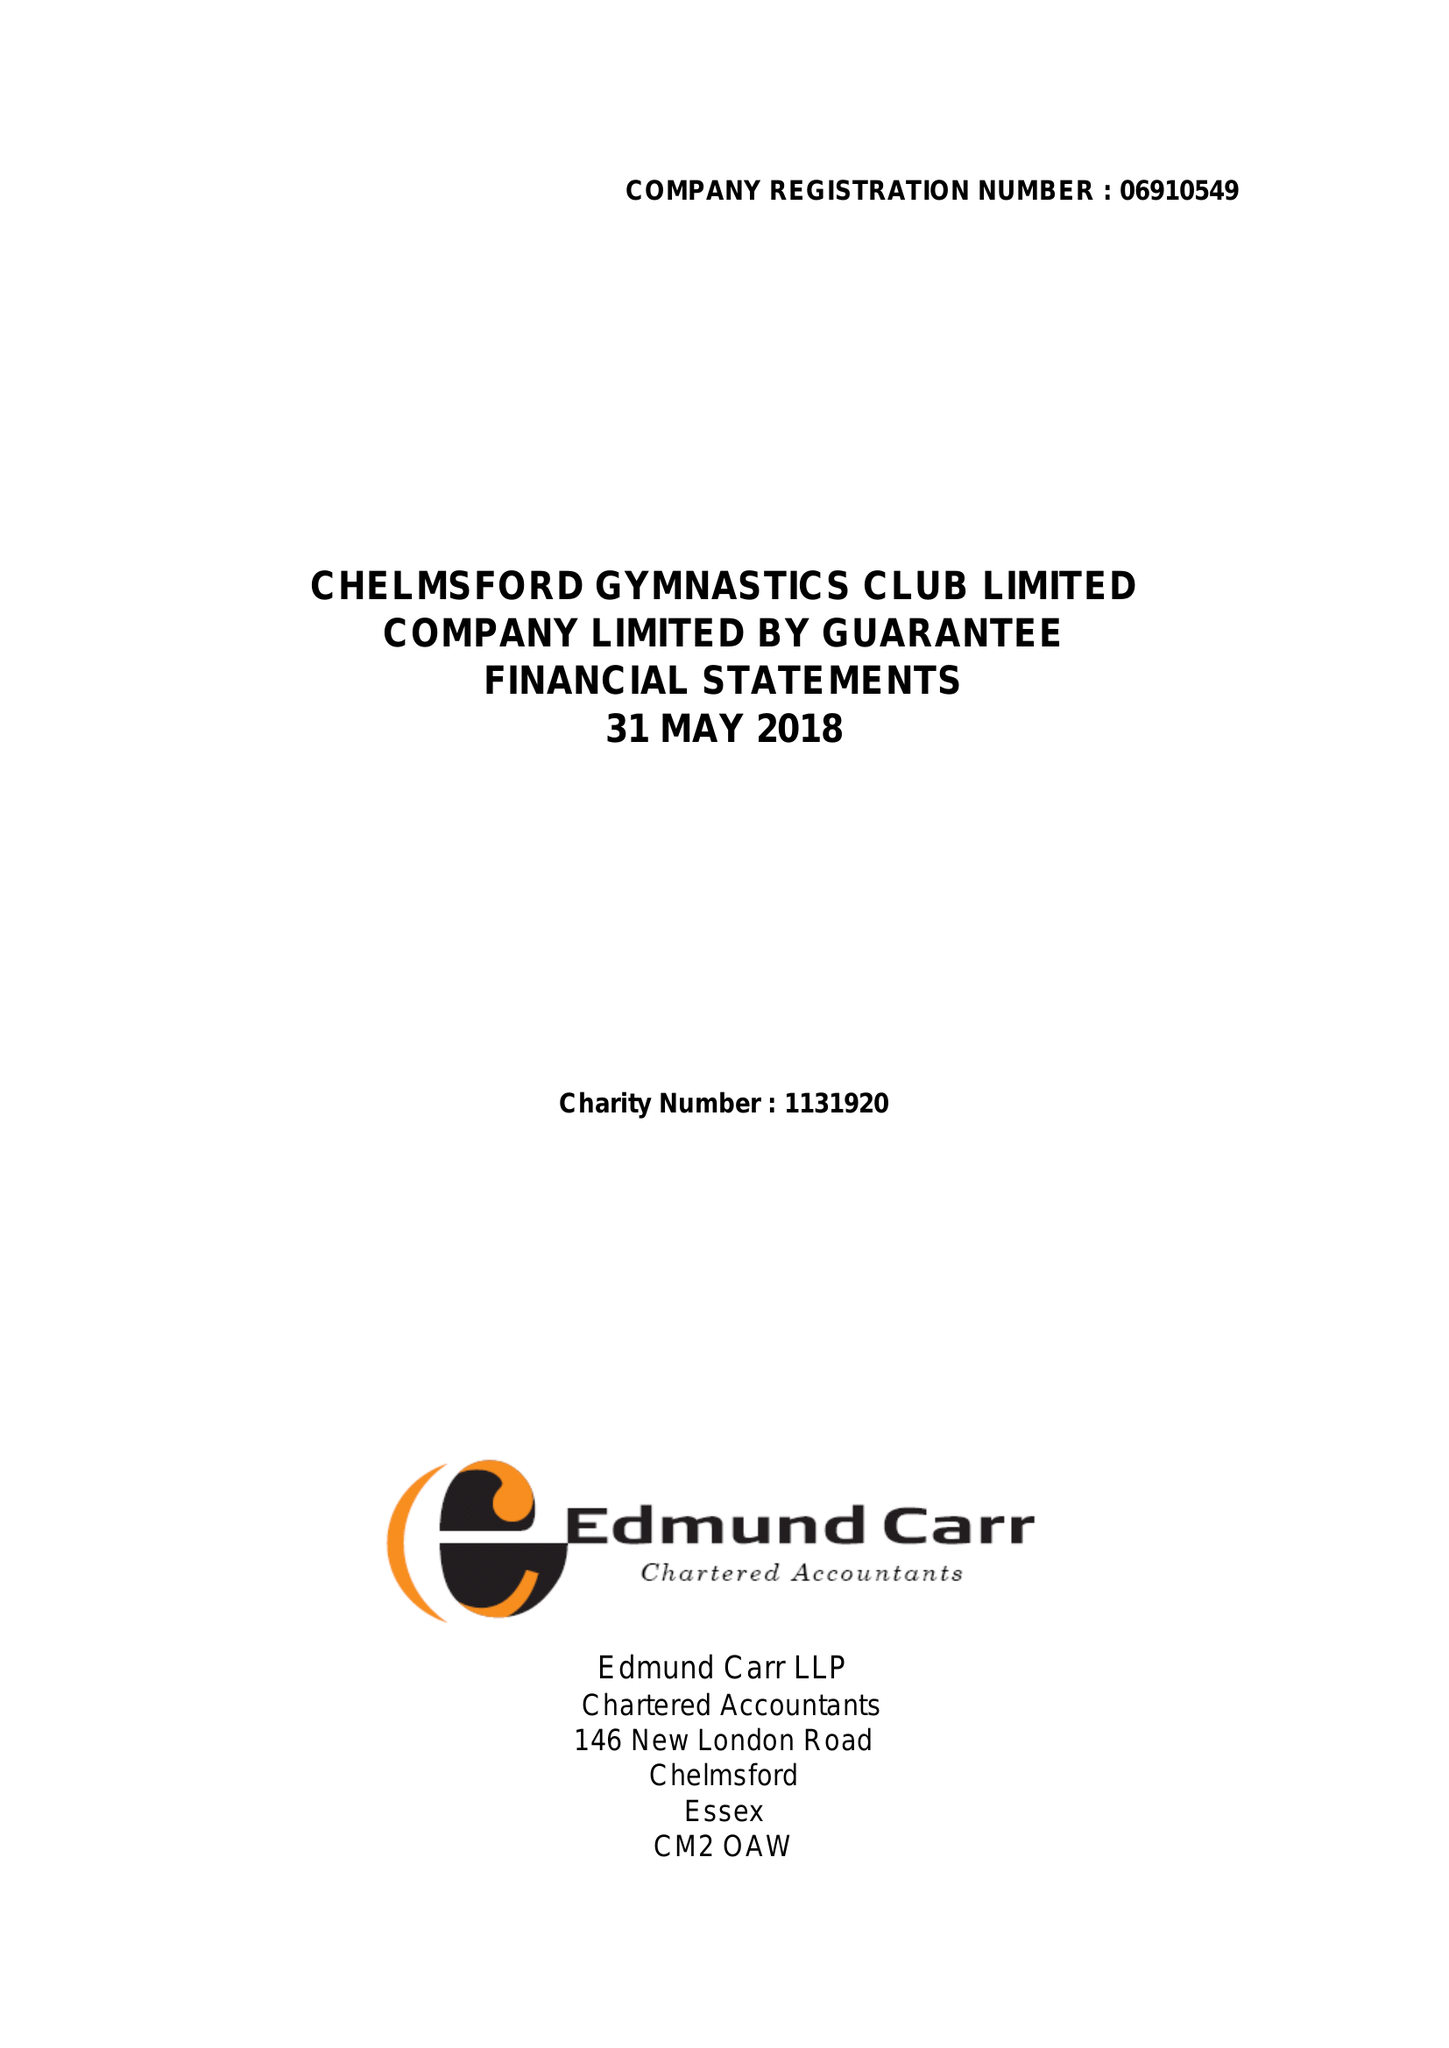What is the value for the address__postcode?
Answer the question using a single word or phrase. CM2 6BX 